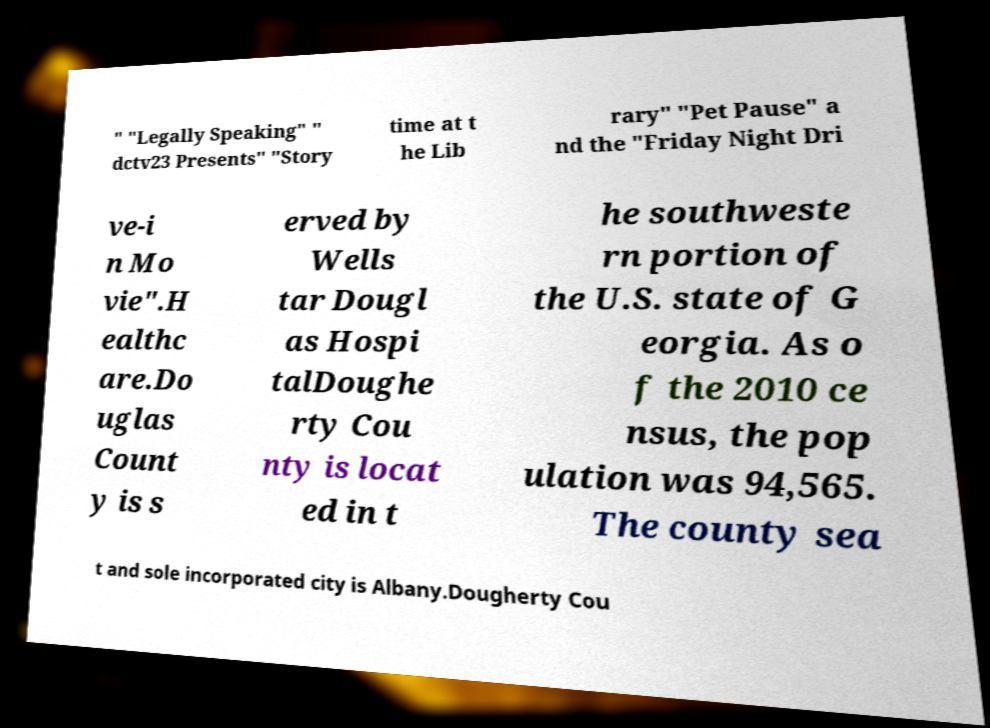Could you assist in decoding the text presented in this image and type it out clearly? " "Legally Speaking" " dctv23 Presents" "Story time at t he Lib rary" "Pet Pause" a nd the "Friday Night Dri ve-i n Mo vie".H ealthc are.Do uglas Count y is s erved by Wells tar Dougl as Hospi talDoughe rty Cou nty is locat ed in t he southweste rn portion of the U.S. state of G eorgia. As o f the 2010 ce nsus, the pop ulation was 94,565. The county sea t and sole incorporated city is Albany.Dougherty Cou 